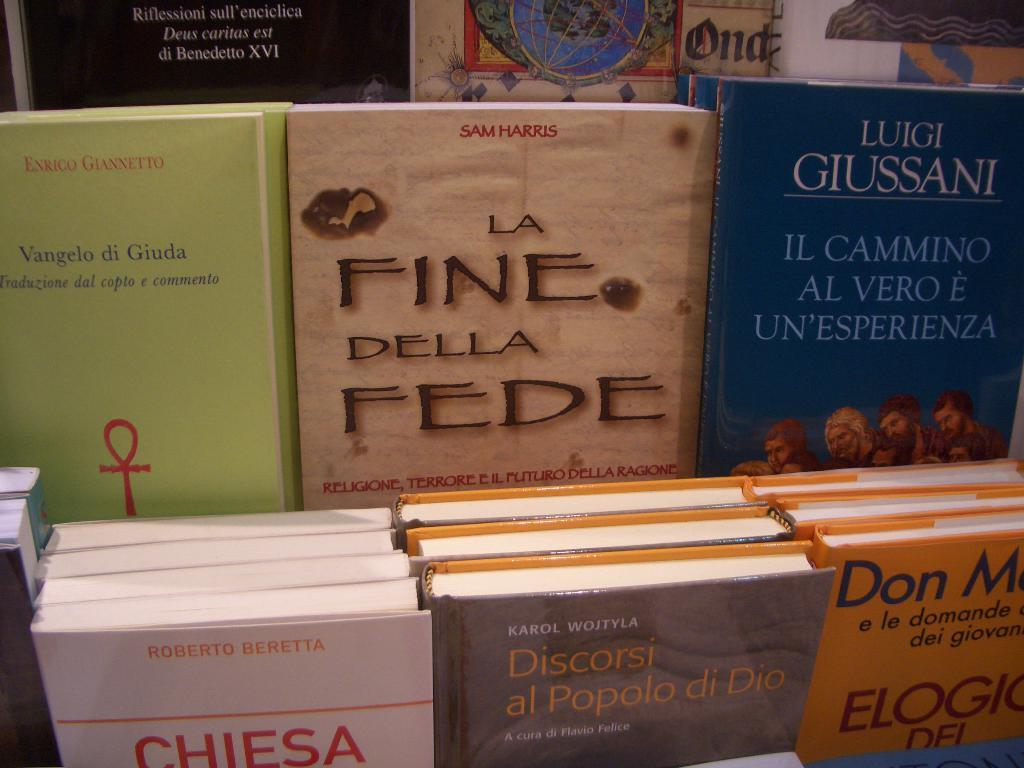<image>
Give a short and clear explanation of the subsequent image. One of the book authors is the writer Luigi Giussani. 